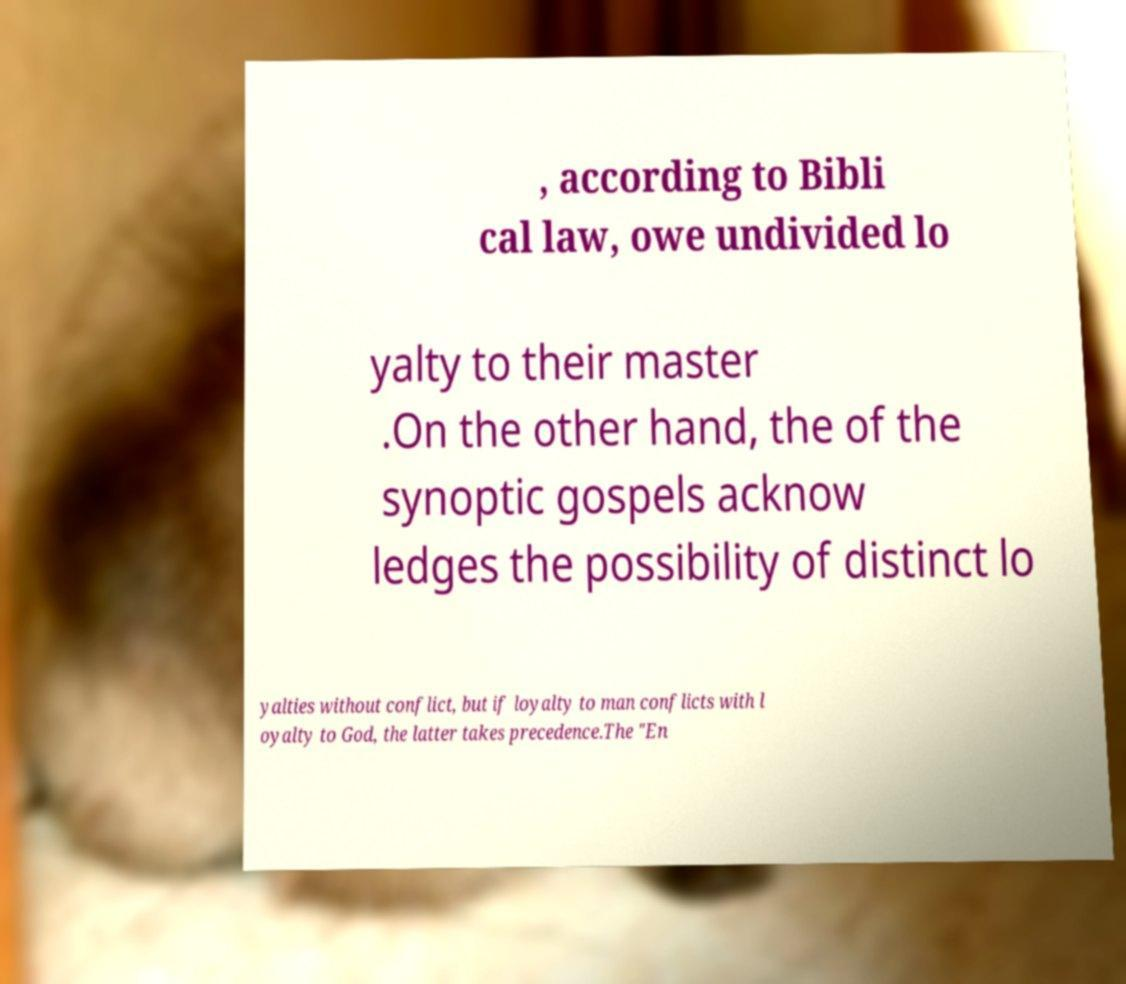Could you assist in decoding the text presented in this image and type it out clearly? , according to Bibli cal law, owe undivided lo yalty to their master .On the other hand, the of the synoptic gospels acknow ledges the possibility of distinct lo yalties without conflict, but if loyalty to man conflicts with l oyalty to God, the latter takes precedence.The "En 